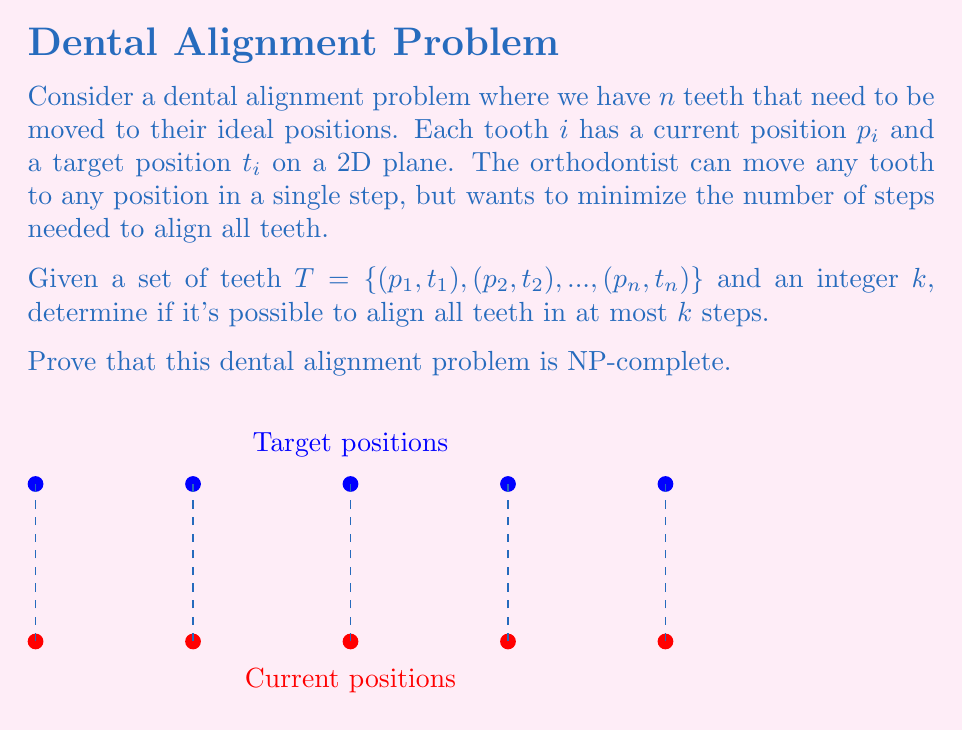Can you solve this math problem? To prove that the dental alignment problem is NP-complete, we need to show that it is both in NP and NP-hard.

1. Prove the problem is in NP:
   - A solution can be verified in polynomial time by checking if all teeth are in their target positions and if the number of steps is at most $k$.
   - This verification can be done in $O(n)$ time, where $n$ is the number of teeth.

2. Prove the problem is NP-hard by reducing a known NP-complete problem to it. We'll use the Set Cover problem:

   Set Cover: Given a universe $U$, a collection of subsets $S = \{S_1, S_2, ..., S_m\}$ of $U$, and an integer $k$, determine if there exists a subset of $S$ with at most $k$ sets that covers all elements in $U$.

   Reduction:
   - For each element $u_i \in U$, create a tooth with current position $p_i = (i, 0)$ and target position $t_i = (i, 1)$.
   - For each subset $S_j \in S$, create a possible move that aligns all teeth corresponding to elements in $S_j$.
   - The goal is to align all teeth in at most $k$ steps.

3. Prove the reduction is correct:
   - If there exists a set cover of size $k$ or less, then we can align all teeth in $k$ or fewer steps by applying the moves corresponding to the selected subsets.
   - Conversely, if we can align all teeth in $k$ or fewer steps, then the subsets corresponding to those moves form a set cover of size $k$ or less.

4. Prove the reduction is polynomial-time:
   - The reduction creates $n = |U|$ teeth and $m = |S|$ possible moves.
   - The reduction can be performed in $O(n + m)$ time.

Since the dental alignment problem is both in NP and NP-hard, it is NP-complete.
Answer: NP-complete 